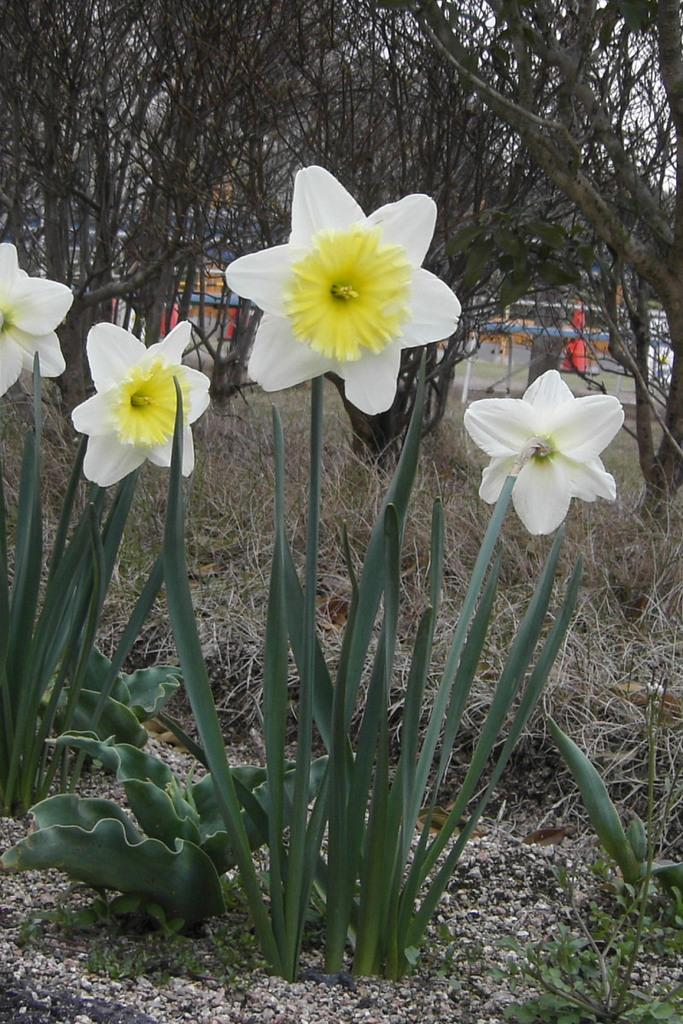What type of flowers are on the plants in the image? There are white flowers on the plants in the image. What is the condition of the grass in the image? The grass in the image is dry. What can be seen in the background of the image? There are trees in the background of the image. What type of sock is hanging on the tree in the image? There is no sock present in the image; it features white flowers on plants, dry grass, and trees in the background. 